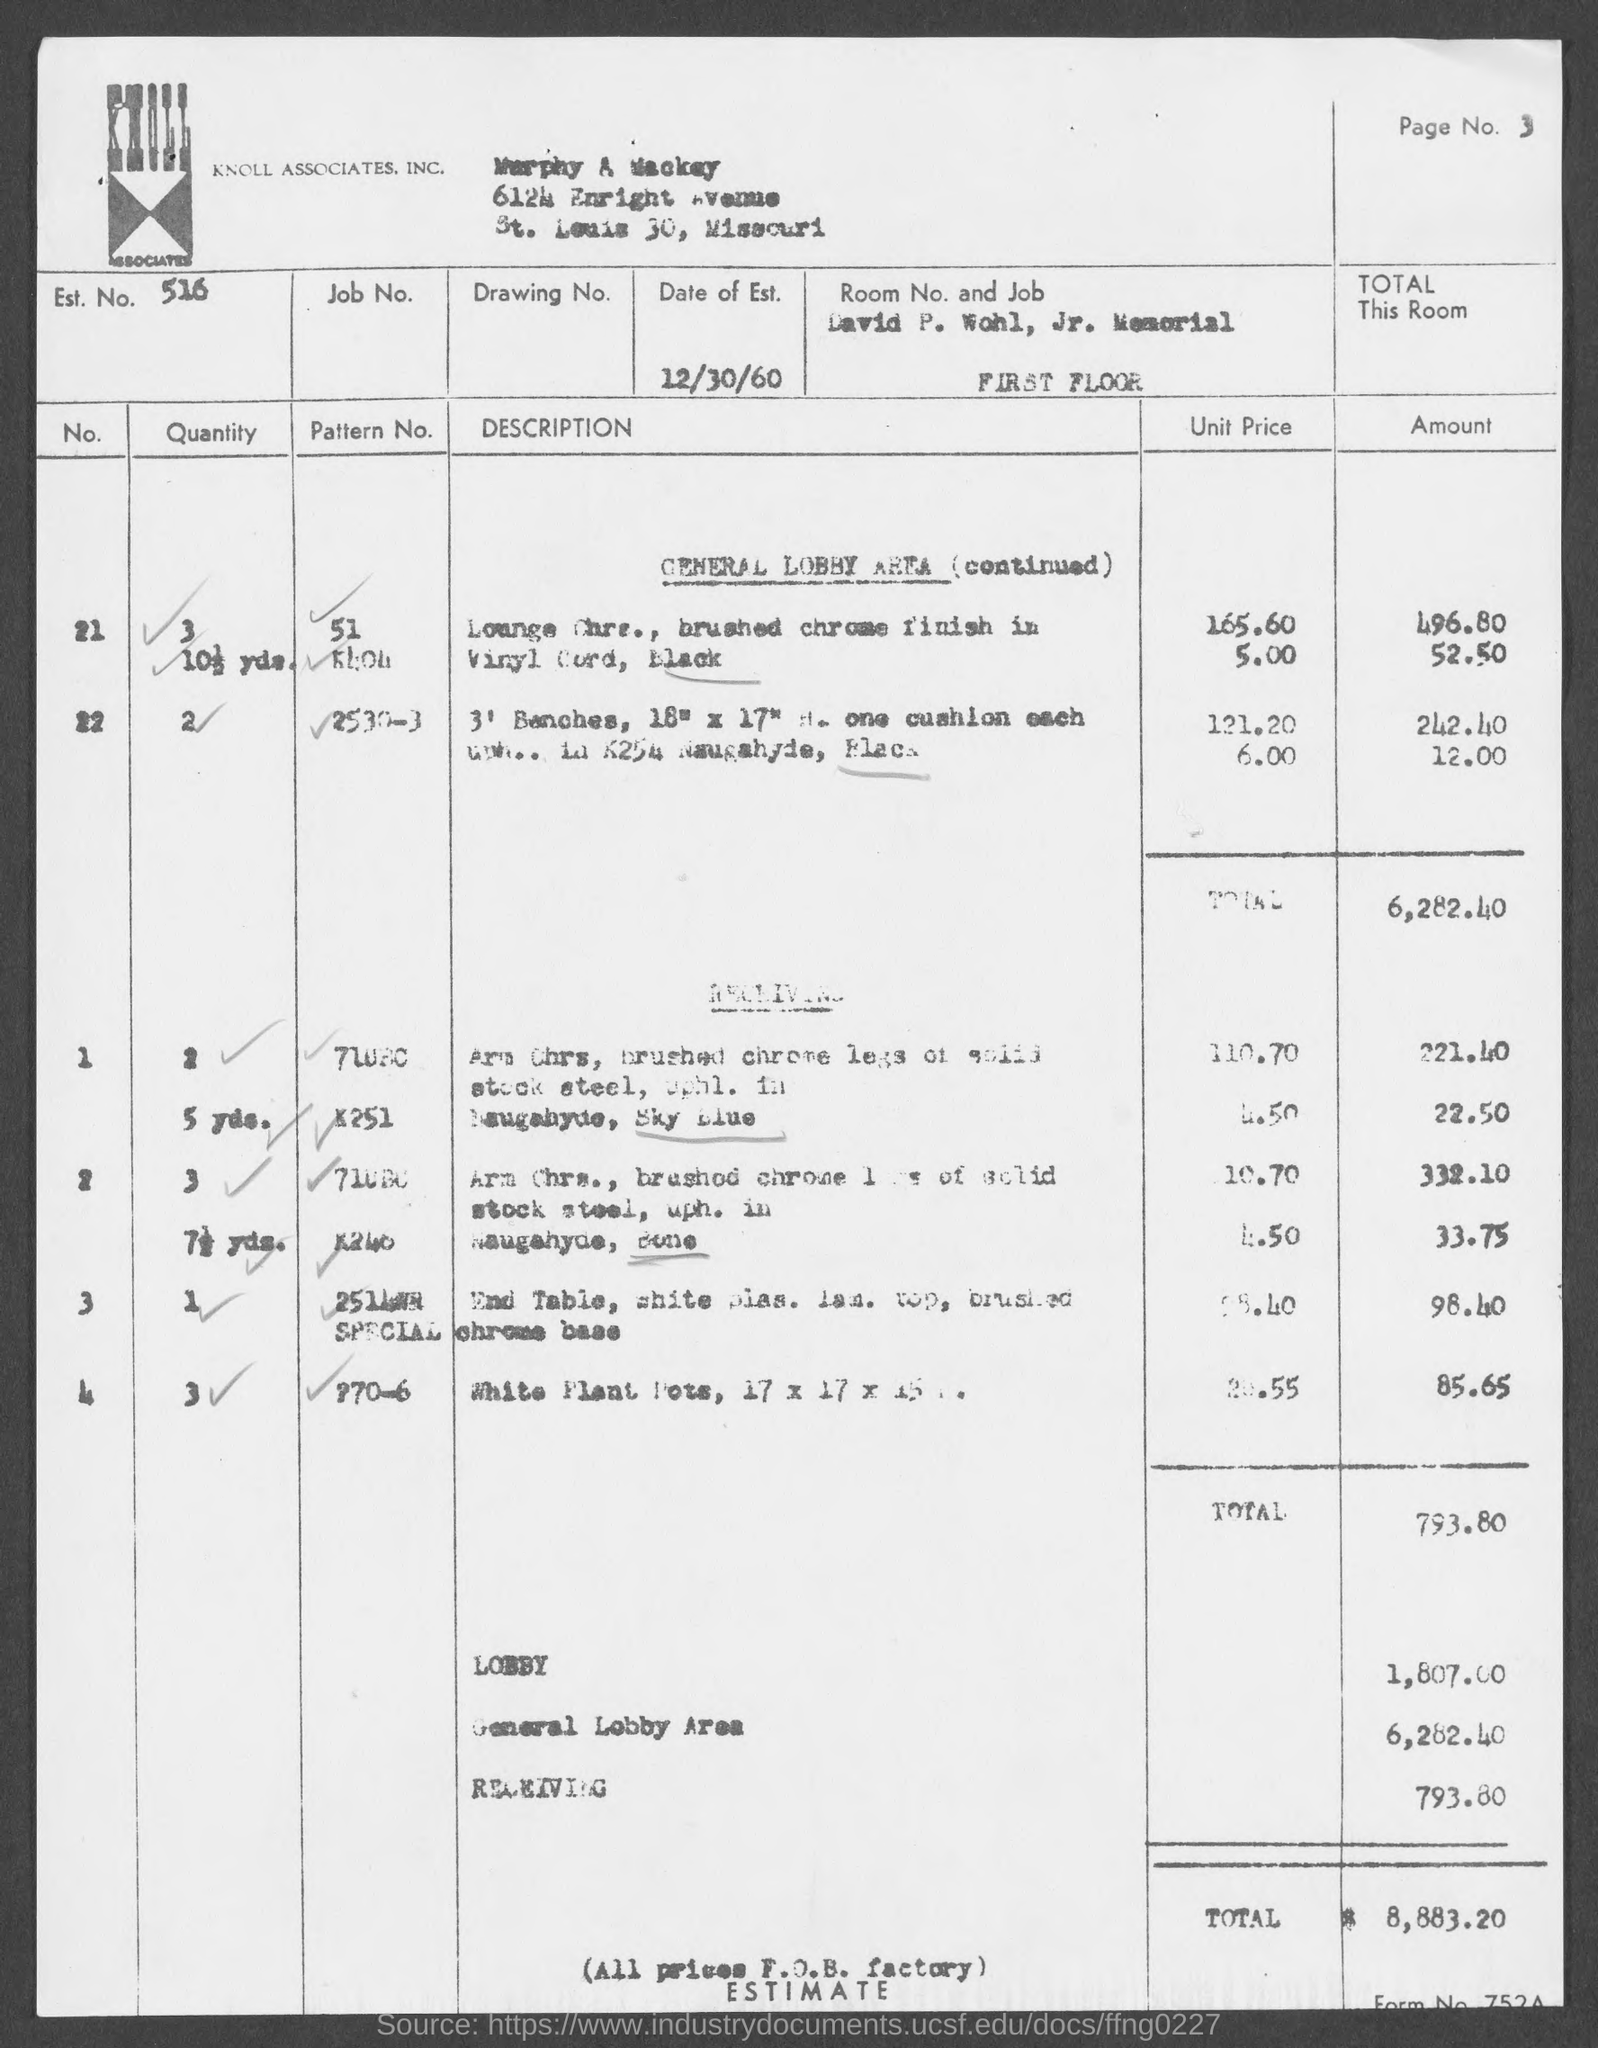List a handful of essential elements in this visual. The estimated amount for the general lobby area mentioned in the document is 6,282.40. Knoll Associates, Inc. is the company mentioned in the header of the document. According to the document, the estimated amount for LOBBY is 1,807.00. The estimate number mentioned in the document is 516... The estimated amount for the receiving area is stated in the document as 793.80. 